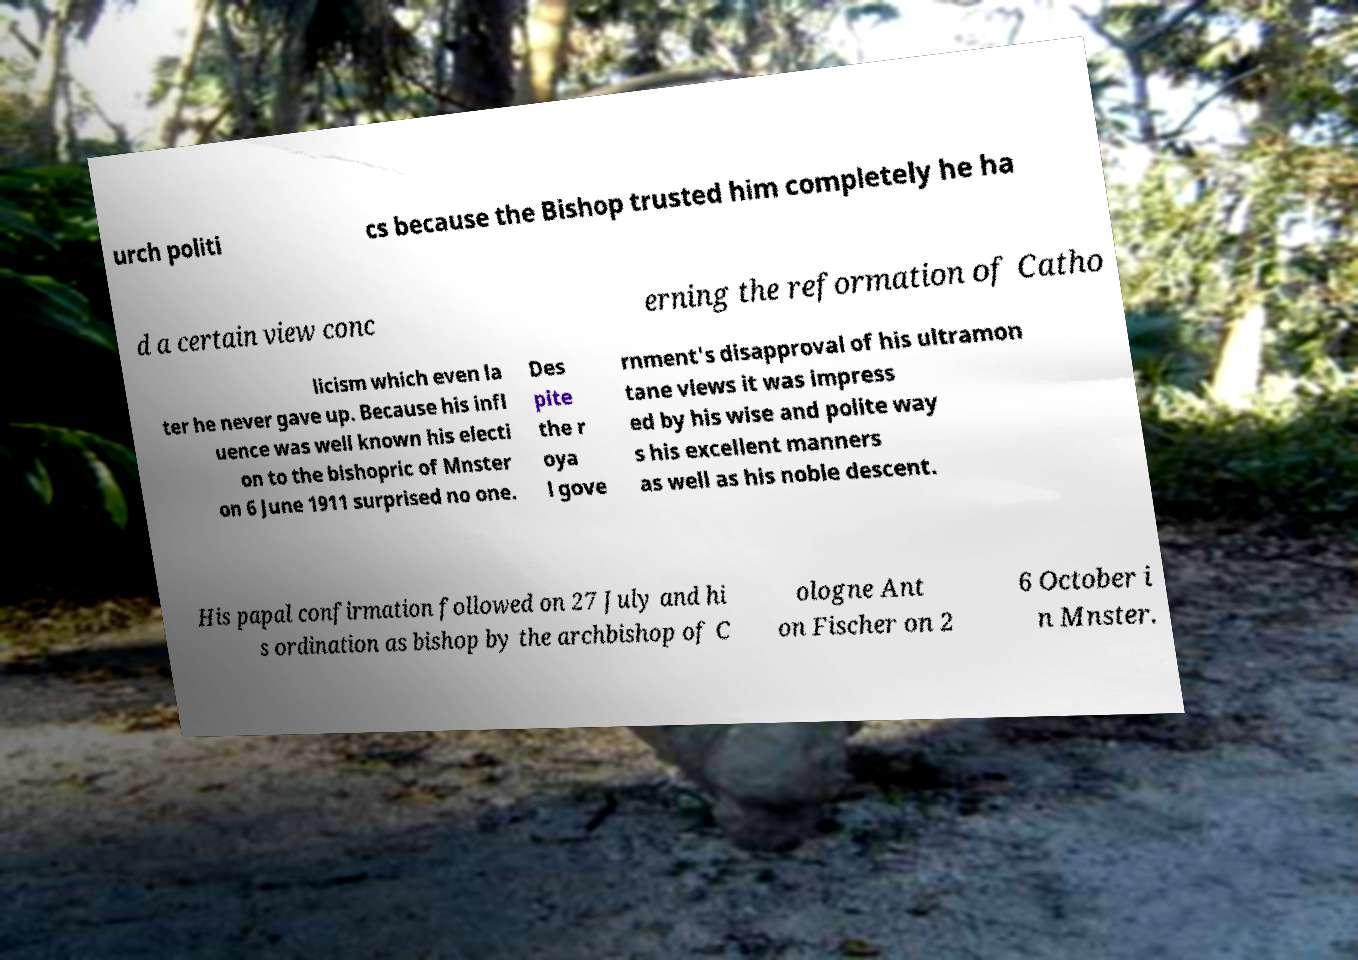Please read and relay the text visible in this image. What does it say? urch politi cs because the Bishop trusted him completely he ha d a certain view conc erning the reformation of Catho licism which even la ter he never gave up. Because his infl uence was well known his electi on to the bishopric of Mnster on 6 June 1911 surprised no one. Des pite the r oya l gove rnment's disapproval of his ultramon tane views it was impress ed by his wise and polite way s his excellent manners as well as his noble descent. His papal confirmation followed on 27 July and hi s ordination as bishop by the archbishop of C ologne Ant on Fischer on 2 6 October i n Mnster. 